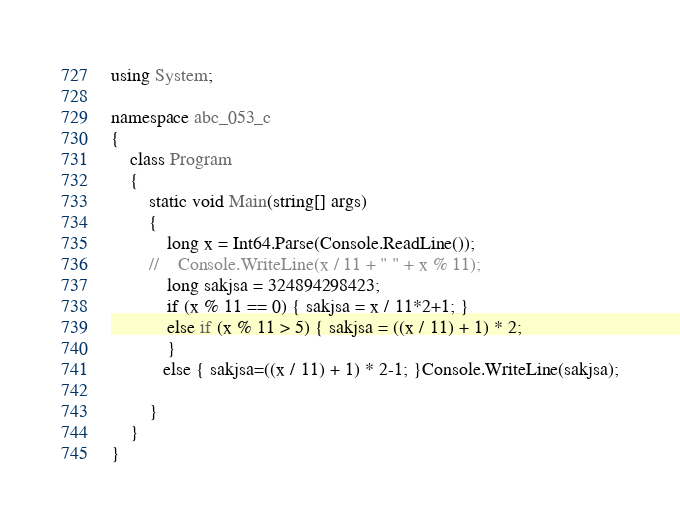<code> <loc_0><loc_0><loc_500><loc_500><_C#_>using System;

namespace abc_053_c
{
    class Program
    {
        static void Main(string[] args)
        {
            long x = Int64.Parse(Console.ReadLine());
        //    Console.WriteLine(x / 11 + " " + x % 11);
            long sakjsa = 324894298423;
            if (x % 11 == 0) { sakjsa = x / 11*2+1; }
            else if (x % 11 > 5) { sakjsa = ((x / 11) + 1) * 2;
            }
           else { sakjsa=((x / 11) + 1) * 2-1; }Console.WriteLine(sakjsa);
            
        }
    }
}
</code> 